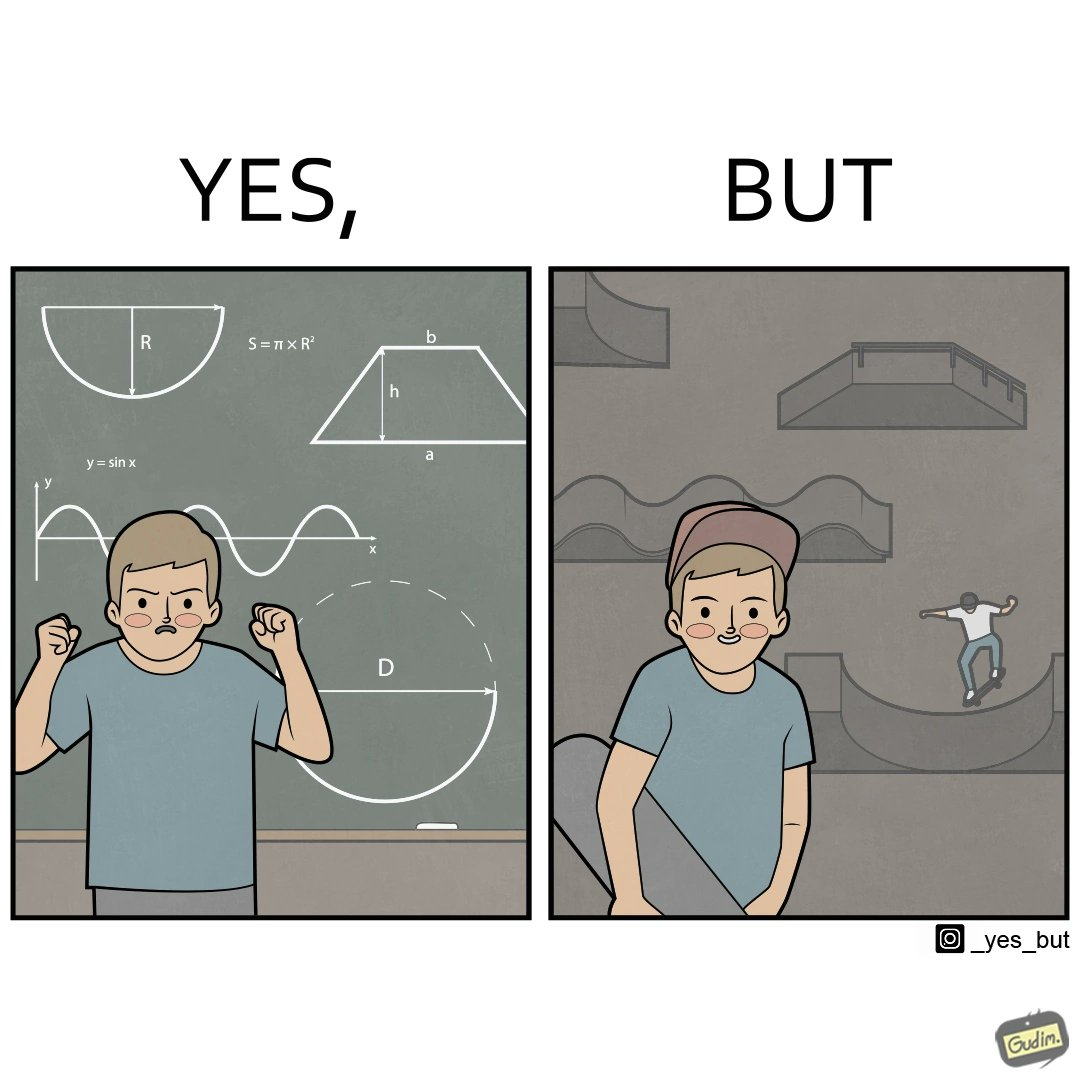Why is this image considered satirical? The image is ironical beaucse while the boy does not enjoy studying mathematics and different geometric shapes like semi circle and trapezoid and graphs of trigonometric equations like that of a sine wave, he enjoys skateboarding on surfaces and bowls that are built based on the said geometric shapes and graphs of trigonometric equations. 